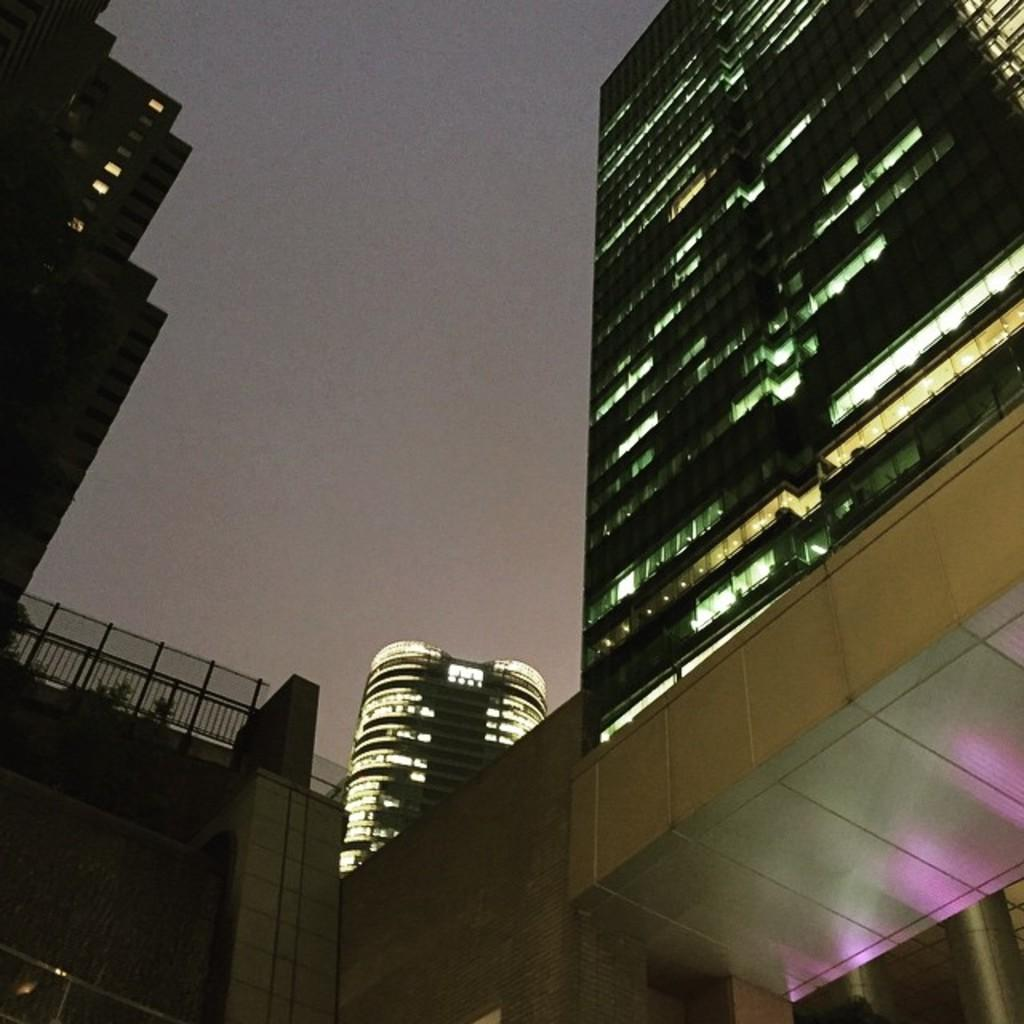What type of structures are visible in the image? There are buildings with lights in the image. What can be seen near the buildings? There is a railing in the image. What type of vegetation is present in the image? There are plants in the image. What is visible in the background of the image? The sky is visible in the background of the image. What type of books can be seen on the army soldiers in the image? There are no army soldiers or books present in the image. What flavor of jelly is being served at the event in the image? There is no event or jelly present in the image. 